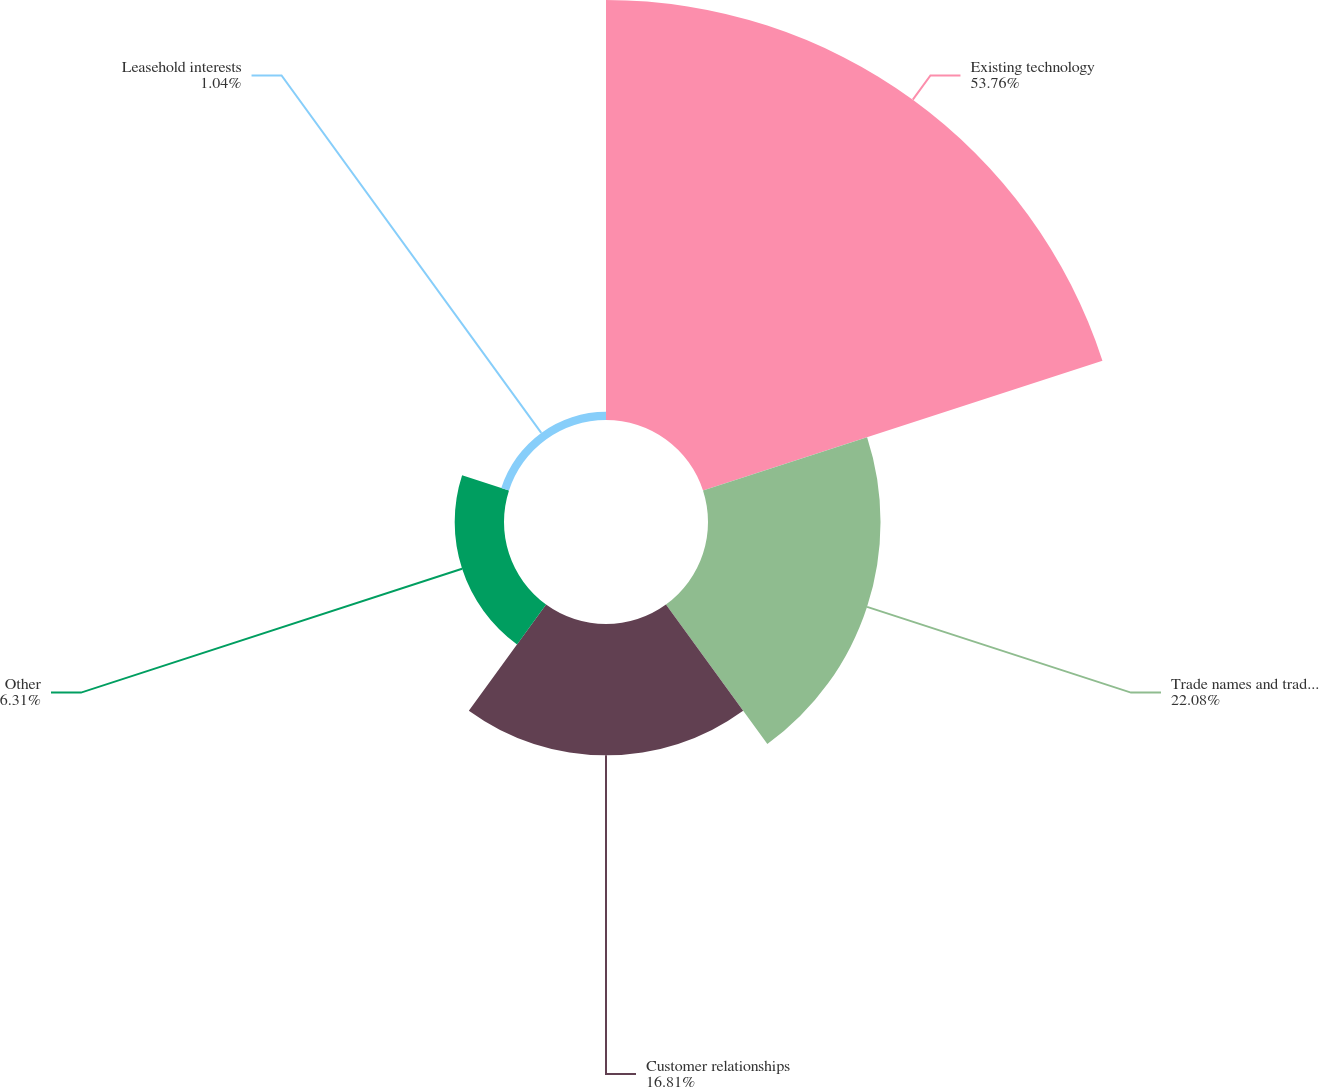<chart> <loc_0><loc_0><loc_500><loc_500><pie_chart><fcel>Existing technology<fcel>Trade names and trademarks<fcel>Customer relationships<fcel>Other<fcel>Leasehold interests<nl><fcel>53.75%<fcel>22.08%<fcel>16.81%<fcel>6.31%<fcel>1.04%<nl></chart> 